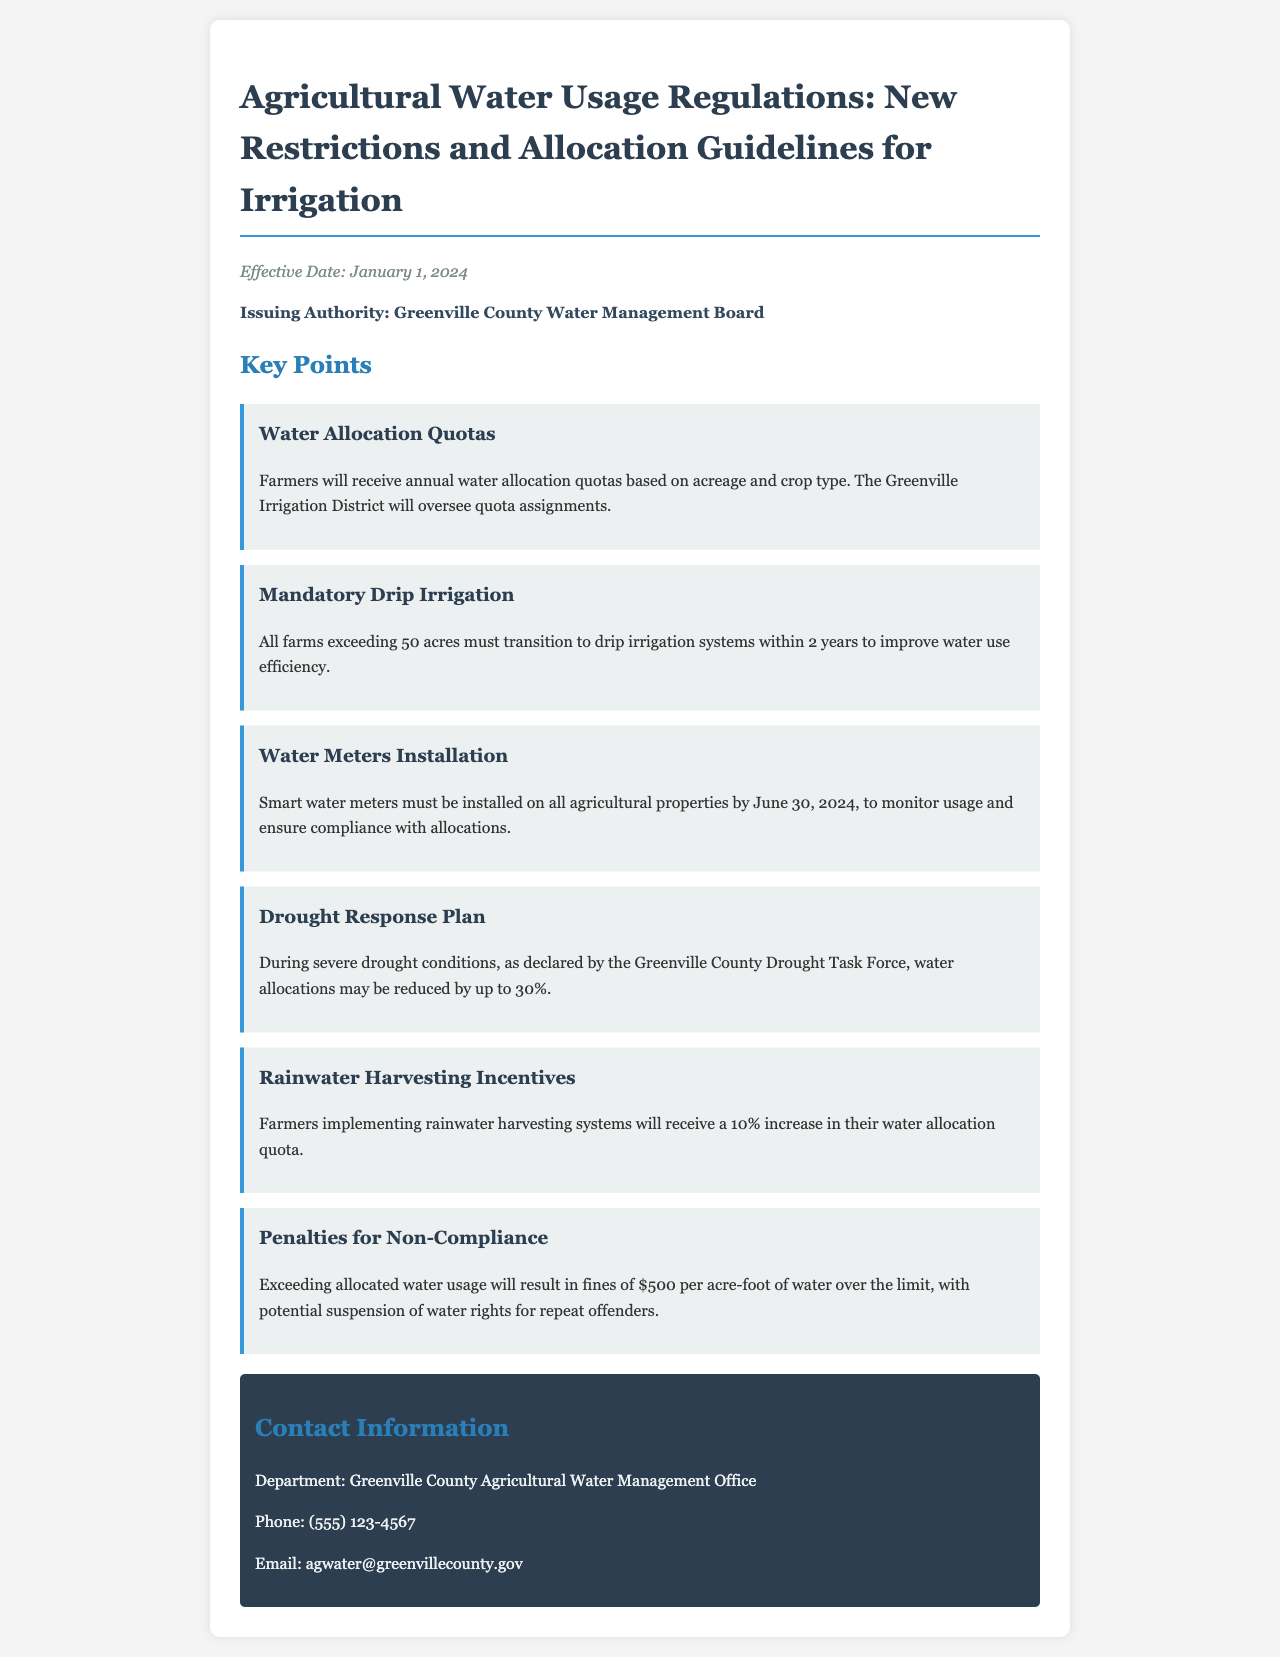What is the effective date of the regulations? The effective date is stated at the beginning of the document.
Answer: January 1, 2024 Who oversees the water allocation quotas? The document mentions the organization responsible for quota assignments.
Answer: Greenville Irrigation District What is the water usage penalty for exceeding the allocated amount? The penalty for non-compliance is specified in the document.
Answer: $500 per acre-foot What irrigation system must farms over 50 acres implement? The document specifies a new requirement for larger farms regarding irrigation systems.
Answer: Drip irrigation What increase in water allocation quota is provided for rainwater harvesting systems? The document outlines incentives for implementing specific water-saving practices.
Answer: 10% increase During severe drought, by what percentage may water allocations be reduced? The document states the potential reduction in allocations during drought conditions.
Answer: 30% By when must smart water meters be installed on all agricultural properties? The timeline for the installation of water meters is given in the document.
Answer: June 30, 2024 What authority issued the water usage regulations? The document attributes the issuance of the regulations to a specific authority.
Answer: Greenville County Water Management Board What is the main purpose of the new regulations? The objective of the document is implied throughout its content.
Answer: Sustainable water usage 